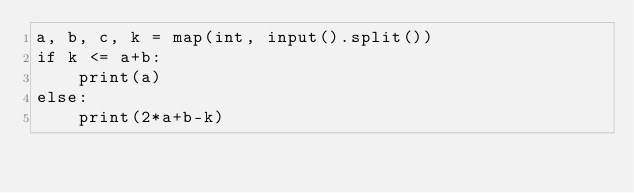Convert code to text. <code><loc_0><loc_0><loc_500><loc_500><_Python_>a, b, c, k = map(int, input().split())
if k <= a+b:
    print(a)
else:
    print(2*a+b-k)</code> 